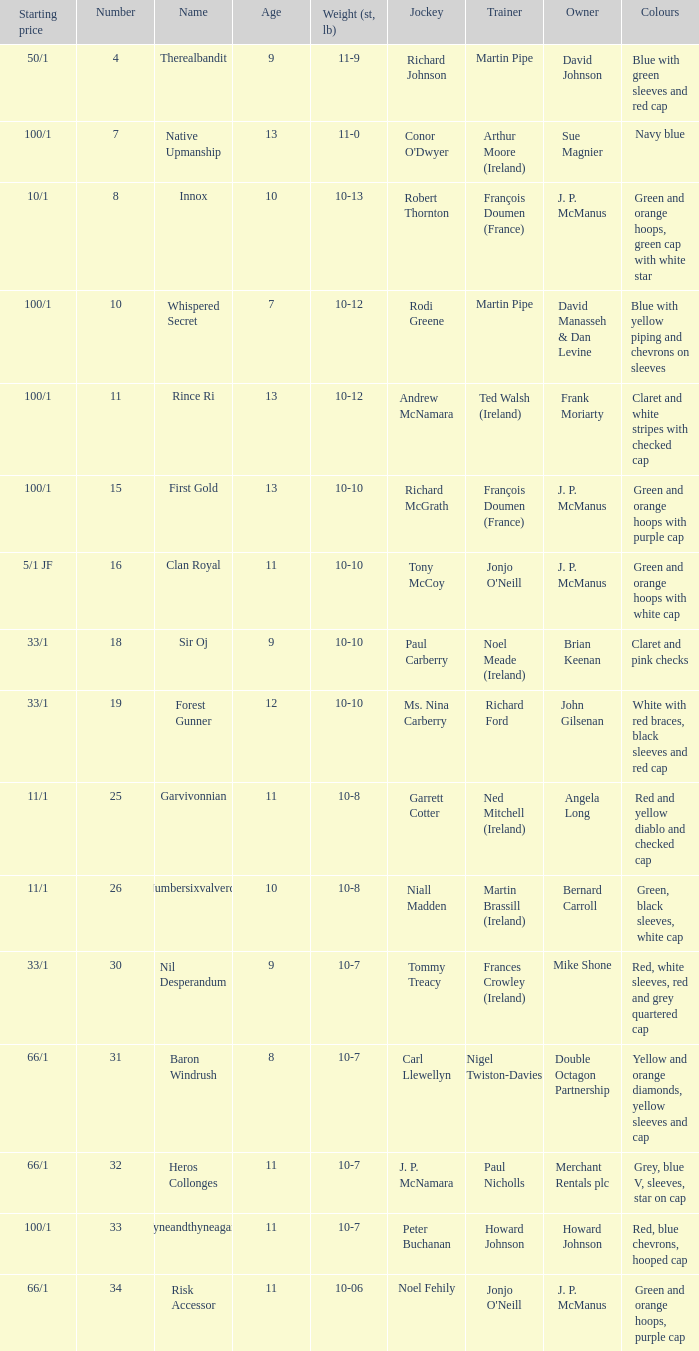What was the name that had a starting price of 11/1 and a jockey named Garrett Cotter? Garvivonnian. 